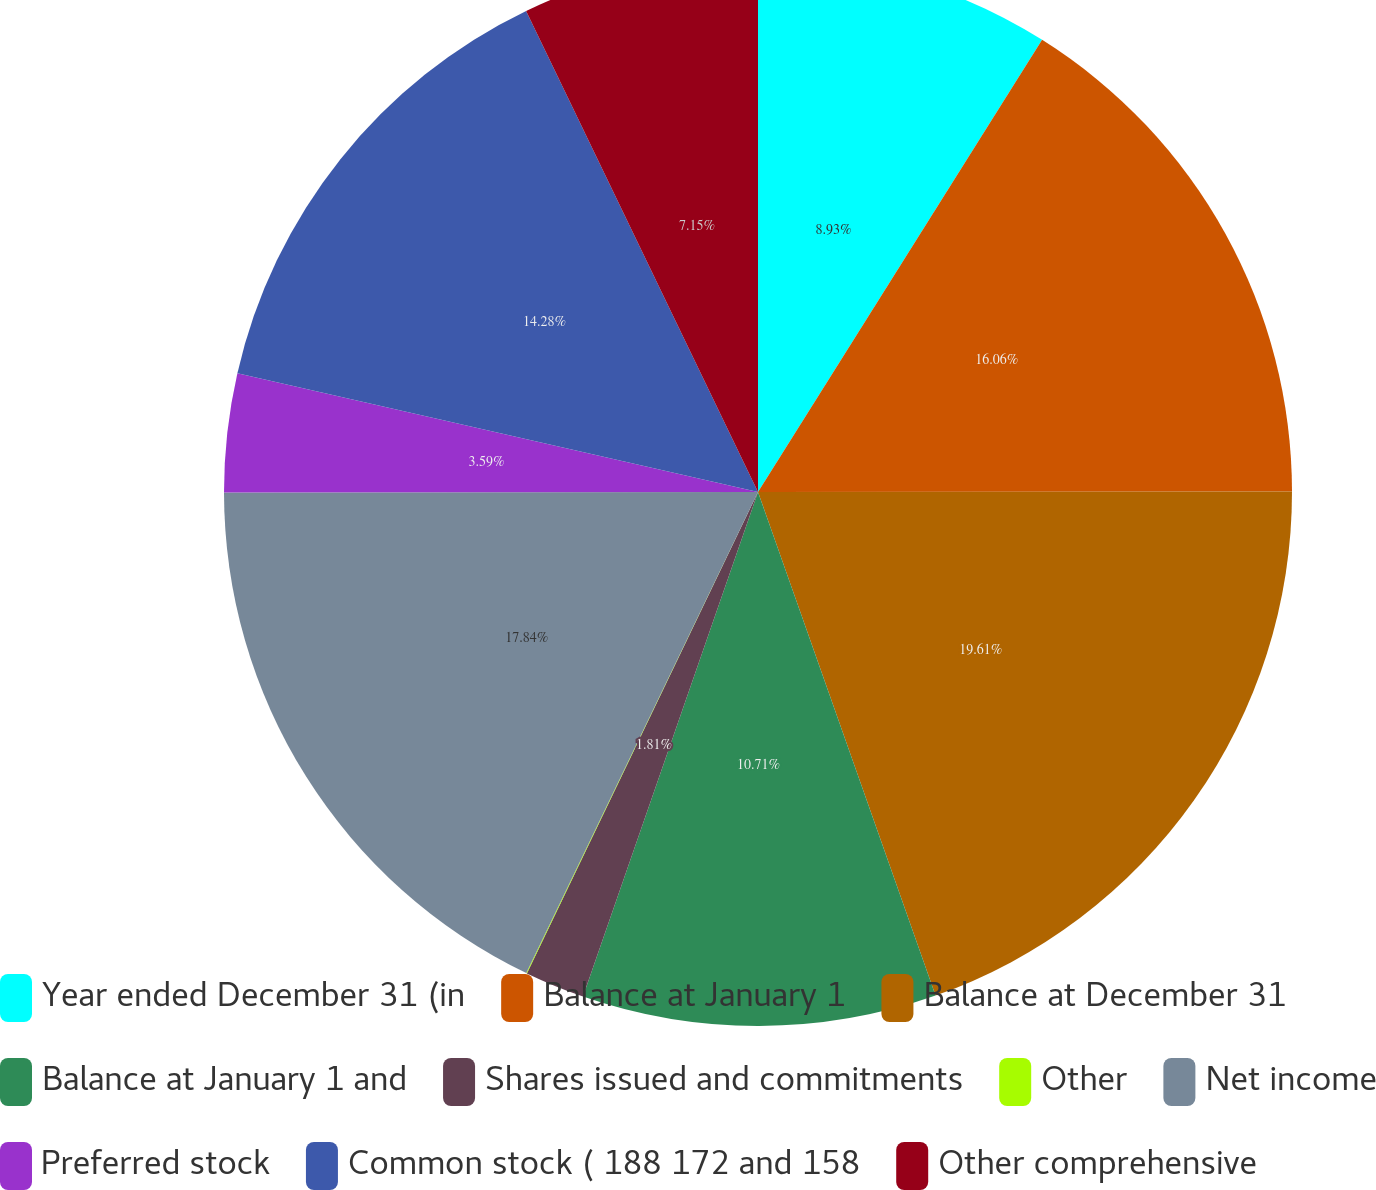<chart> <loc_0><loc_0><loc_500><loc_500><pie_chart><fcel>Year ended December 31 (in<fcel>Balance at January 1<fcel>Balance at December 31<fcel>Balance at January 1 and<fcel>Shares issued and commitments<fcel>Other<fcel>Net income<fcel>Preferred stock<fcel>Common stock ( 188 172 and 158<fcel>Other comprehensive<nl><fcel>8.93%<fcel>16.06%<fcel>19.62%<fcel>10.71%<fcel>1.81%<fcel>0.02%<fcel>17.84%<fcel>3.59%<fcel>14.28%<fcel>7.15%<nl></chart> 